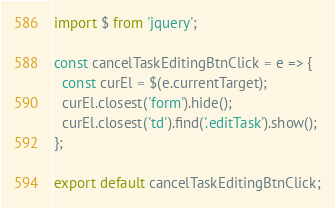<code> <loc_0><loc_0><loc_500><loc_500><_JavaScript_>import $ from 'jquery';

const cancelTaskEditingBtnClick = e => {
  const curEl = $(e.currentTarget);
  curEl.closest('form').hide();
  curEl.closest('td').find('.editTask').show();
};

export default cancelTaskEditingBtnClick;
</code> 